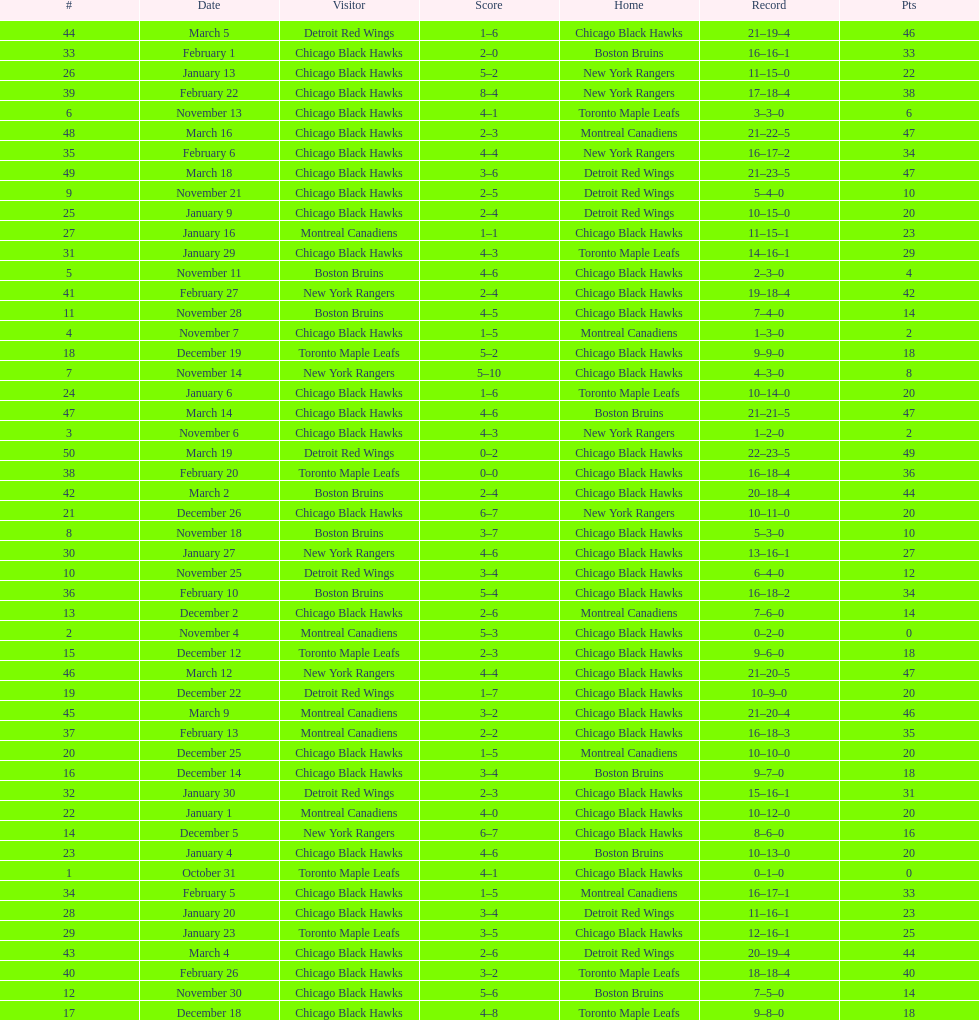Who was the next team that the boston bruins played after november 11? Chicago Black Hawks. 